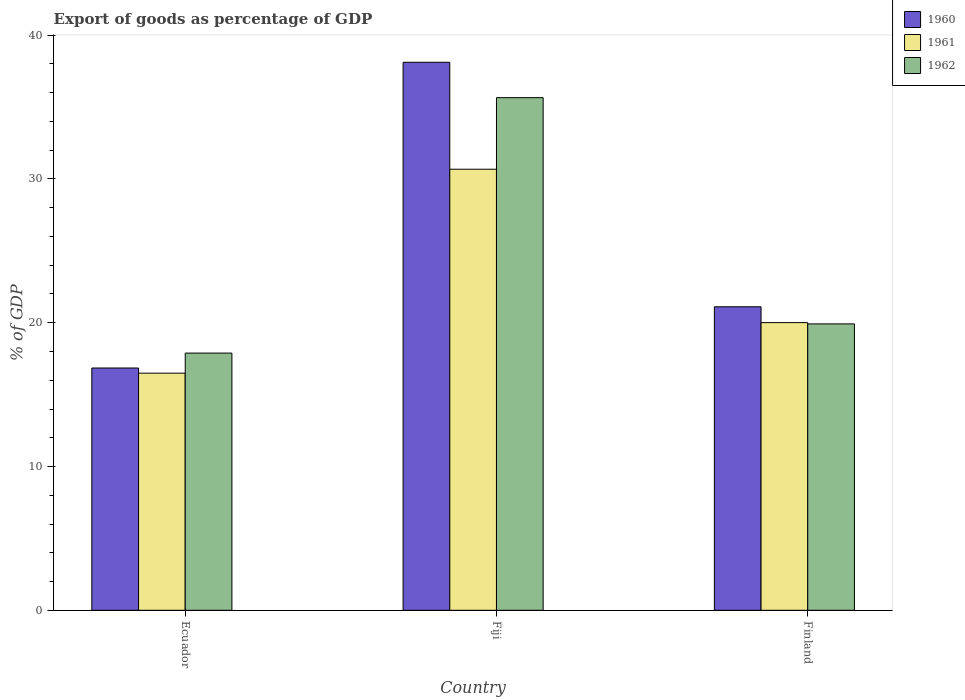How many different coloured bars are there?
Keep it short and to the point. 3. How many groups of bars are there?
Ensure brevity in your answer.  3. Are the number of bars on each tick of the X-axis equal?
Your answer should be compact. Yes. What is the label of the 3rd group of bars from the left?
Your answer should be very brief. Finland. In how many cases, is the number of bars for a given country not equal to the number of legend labels?
Offer a terse response. 0. What is the export of goods as percentage of GDP in 1960 in Finland?
Make the answer very short. 21.11. Across all countries, what is the maximum export of goods as percentage of GDP in 1962?
Provide a succinct answer. 35.66. Across all countries, what is the minimum export of goods as percentage of GDP in 1960?
Provide a short and direct response. 16.85. In which country was the export of goods as percentage of GDP in 1962 maximum?
Make the answer very short. Fiji. In which country was the export of goods as percentage of GDP in 1960 minimum?
Provide a short and direct response. Ecuador. What is the total export of goods as percentage of GDP in 1961 in the graph?
Offer a terse response. 67.18. What is the difference between the export of goods as percentage of GDP in 1962 in Ecuador and that in Fiji?
Your answer should be very brief. -17.77. What is the difference between the export of goods as percentage of GDP in 1962 in Ecuador and the export of goods as percentage of GDP in 1960 in Finland?
Offer a very short reply. -3.22. What is the average export of goods as percentage of GDP in 1962 per country?
Ensure brevity in your answer.  24.49. What is the difference between the export of goods as percentage of GDP of/in 1961 and export of goods as percentage of GDP of/in 1962 in Ecuador?
Keep it short and to the point. -1.4. What is the ratio of the export of goods as percentage of GDP in 1960 in Ecuador to that in Fiji?
Give a very brief answer. 0.44. What is the difference between the highest and the second highest export of goods as percentage of GDP in 1961?
Your answer should be compact. -3.52. What is the difference between the highest and the lowest export of goods as percentage of GDP in 1960?
Give a very brief answer. 21.26. In how many countries, is the export of goods as percentage of GDP in 1962 greater than the average export of goods as percentage of GDP in 1962 taken over all countries?
Give a very brief answer. 1. Is the sum of the export of goods as percentage of GDP in 1961 in Ecuador and Fiji greater than the maximum export of goods as percentage of GDP in 1960 across all countries?
Your response must be concise. Yes. What does the 1st bar from the right in Finland represents?
Your answer should be very brief. 1962. Are all the bars in the graph horizontal?
Your answer should be compact. No. What is the difference between two consecutive major ticks on the Y-axis?
Give a very brief answer. 10. Does the graph contain grids?
Provide a succinct answer. No. Where does the legend appear in the graph?
Offer a very short reply. Top right. How are the legend labels stacked?
Your answer should be very brief. Vertical. What is the title of the graph?
Provide a succinct answer. Export of goods as percentage of GDP. What is the label or title of the Y-axis?
Keep it short and to the point. % of GDP. What is the % of GDP in 1960 in Ecuador?
Make the answer very short. 16.85. What is the % of GDP of 1961 in Ecuador?
Offer a terse response. 16.49. What is the % of GDP in 1962 in Ecuador?
Offer a very short reply. 17.89. What is the % of GDP in 1960 in Fiji?
Your response must be concise. 38.12. What is the % of GDP in 1961 in Fiji?
Your response must be concise. 30.68. What is the % of GDP of 1962 in Fiji?
Your response must be concise. 35.66. What is the % of GDP in 1960 in Finland?
Offer a terse response. 21.11. What is the % of GDP of 1961 in Finland?
Ensure brevity in your answer.  20.01. What is the % of GDP of 1962 in Finland?
Make the answer very short. 19.92. Across all countries, what is the maximum % of GDP in 1960?
Provide a succinct answer. 38.12. Across all countries, what is the maximum % of GDP in 1961?
Offer a terse response. 30.68. Across all countries, what is the maximum % of GDP in 1962?
Ensure brevity in your answer.  35.66. Across all countries, what is the minimum % of GDP of 1960?
Offer a terse response. 16.85. Across all countries, what is the minimum % of GDP of 1961?
Offer a terse response. 16.49. Across all countries, what is the minimum % of GDP of 1962?
Offer a terse response. 17.89. What is the total % of GDP of 1960 in the graph?
Provide a short and direct response. 76.08. What is the total % of GDP in 1961 in the graph?
Provide a succinct answer. 67.18. What is the total % of GDP in 1962 in the graph?
Ensure brevity in your answer.  73.47. What is the difference between the % of GDP of 1960 in Ecuador and that in Fiji?
Give a very brief answer. -21.26. What is the difference between the % of GDP in 1961 in Ecuador and that in Fiji?
Make the answer very short. -14.18. What is the difference between the % of GDP in 1962 in Ecuador and that in Fiji?
Make the answer very short. -17.77. What is the difference between the % of GDP of 1960 in Ecuador and that in Finland?
Your answer should be very brief. -4.26. What is the difference between the % of GDP in 1961 in Ecuador and that in Finland?
Make the answer very short. -3.52. What is the difference between the % of GDP of 1962 in Ecuador and that in Finland?
Give a very brief answer. -2.03. What is the difference between the % of GDP in 1960 in Fiji and that in Finland?
Make the answer very short. 17.01. What is the difference between the % of GDP of 1961 in Fiji and that in Finland?
Ensure brevity in your answer.  10.67. What is the difference between the % of GDP in 1962 in Fiji and that in Finland?
Offer a terse response. 15.74. What is the difference between the % of GDP in 1960 in Ecuador and the % of GDP in 1961 in Fiji?
Provide a short and direct response. -13.83. What is the difference between the % of GDP in 1960 in Ecuador and the % of GDP in 1962 in Fiji?
Provide a succinct answer. -18.8. What is the difference between the % of GDP in 1961 in Ecuador and the % of GDP in 1962 in Fiji?
Your answer should be compact. -19.16. What is the difference between the % of GDP of 1960 in Ecuador and the % of GDP of 1961 in Finland?
Provide a short and direct response. -3.16. What is the difference between the % of GDP of 1960 in Ecuador and the % of GDP of 1962 in Finland?
Provide a short and direct response. -3.07. What is the difference between the % of GDP in 1961 in Ecuador and the % of GDP in 1962 in Finland?
Your answer should be very brief. -3.43. What is the difference between the % of GDP of 1960 in Fiji and the % of GDP of 1961 in Finland?
Make the answer very short. 18.11. What is the difference between the % of GDP in 1960 in Fiji and the % of GDP in 1962 in Finland?
Keep it short and to the point. 18.2. What is the difference between the % of GDP of 1961 in Fiji and the % of GDP of 1962 in Finland?
Your response must be concise. 10.76. What is the average % of GDP in 1960 per country?
Keep it short and to the point. 25.36. What is the average % of GDP of 1961 per country?
Your response must be concise. 22.39. What is the average % of GDP in 1962 per country?
Your answer should be very brief. 24.49. What is the difference between the % of GDP in 1960 and % of GDP in 1961 in Ecuador?
Your response must be concise. 0.36. What is the difference between the % of GDP in 1960 and % of GDP in 1962 in Ecuador?
Your response must be concise. -1.04. What is the difference between the % of GDP in 1961 and % of GDP in 1962 in Ecuador?
Your response must be concise. -1.4. What is the difference between the % of GDP of 1960 and % of GDP of 1961 in Fiji?
Your response must be concise. 7.44. What is the difference between the % of GDP in 1960 and % of GDP in 1962 in Fiji?
Provide a succinct answer. 2.46. What is the difference between the % of GDP of 1961 and % of GDP of 1962 in Fiji?
Give a very brief answer. -4.98. What is the difference between the % of GDP of 1960 and % of GDP of 1961 in Finland?
Offer a very short reply. 1.1. What is the difference between the % of GDP of 1960 and % of GDP of 1962 in Finland?
Keep it short and to the point. 1.19. What is the difference between the % of GDP in 1961 and % of GDP in 1962 in Finland?
Your answer should be compact. 0.09. What is the ratio of the % of GDP in 1960 in Ecuador to that in Fiji?
Provide a succinct answer. 0.44. What is the ratio of the % of GDP in 1961 in Ecuador to that in Fiji?
Provide a succinct answer. 0.54. What is the ratio of the % of GDP of 1962 in Ecuador to that in Fiji?
Ensure brevity in your answer.  0.5. What is the ratio of the % of GDP in 1960 in Ecuador to that in Finland?
Your response must be concise. 0.8. What is the ratio of the % of GDP of 1961 in Ecuador to that in Finland?
Keep it short and to the point. 0.82. What is the ratio of the % of GDP of 1962 in Ecuador to that in Finland?
Give a very brief answer. 0.9. What is the ratio of the % of GDP in 1960 in Fiji to that in Finland?
Offer a terse response. 1.81. What is the ratio of the % of GDP in 1961 in Fiji to that in Finland?
Keep it short and to the point. 1.53. What is the ratio of the % of GDP of 1962 in Fiji to that in Finland?
Make the answer very short. 1.79. What is the difference between the highest and the second highest % of GDP of 1960?
Your answer should be compact. 17.01. What is the difference between the highest and the second highest % of GDP in 1961?
Keep it short and to the point. 10.67. What is the difference between the highest and the second highest % of GDP of 1962?
Make the answer very short. 15.74. What is the difference between the highest and the lowest % of GDP of 1960?
Offer a very short reply. 21.26. What is the difference between the highest and the lowest % of GDP in 1961?
Offer a very short reply. 14.18. What is the difference between the highest and the lowest % of GDP in 1962?
Offer a very short reply. 17.77. 